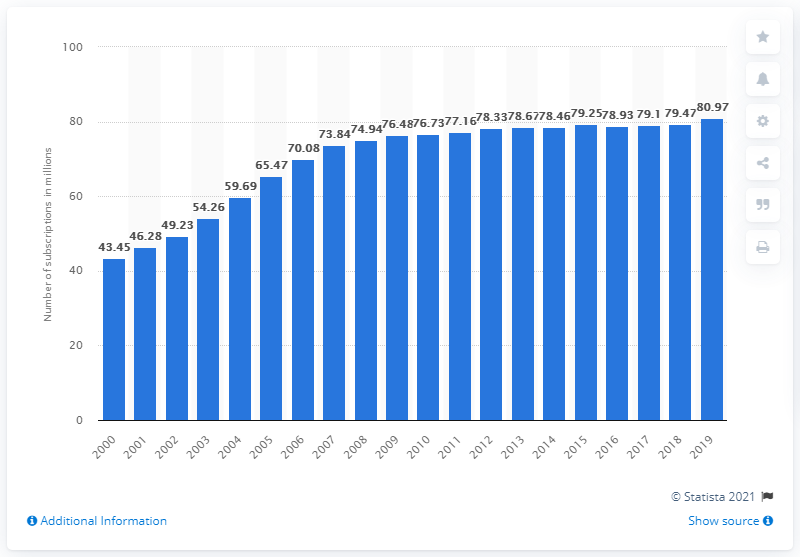Indicate a few pertinent items in this graphic. There were 80.97 million mobile cellular subscriptions registered in the UK between 2000 and 2019. 